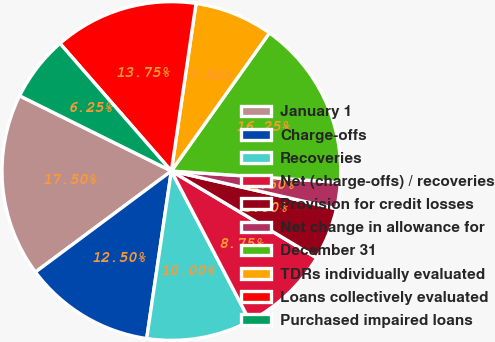Convert chart to OTSL. <chart><loc_0><loc_0><loc_500><loc_500><pie_chart><fcel>January 1<fcel>Charge-offs<fcel>Recoveries<fcel>Net (charge-offs) / recoveries<fcel>Provision for credit losses<fcel>Net change in allowance for<fcel>December 31<fcel>TDRs individually evaluated<fcel>Loans collectively evaluated<fcel>Purchased impaired loans<nl><fcel>17.5%<fcel>12.5%<fcel>10.0%<fcel>8.75%<fcel>5.0%<fcel>2.5%<fcel>16.25%<fcel>7.5%<fcel>13.75%<fcel>6.25%<nl></chart> 